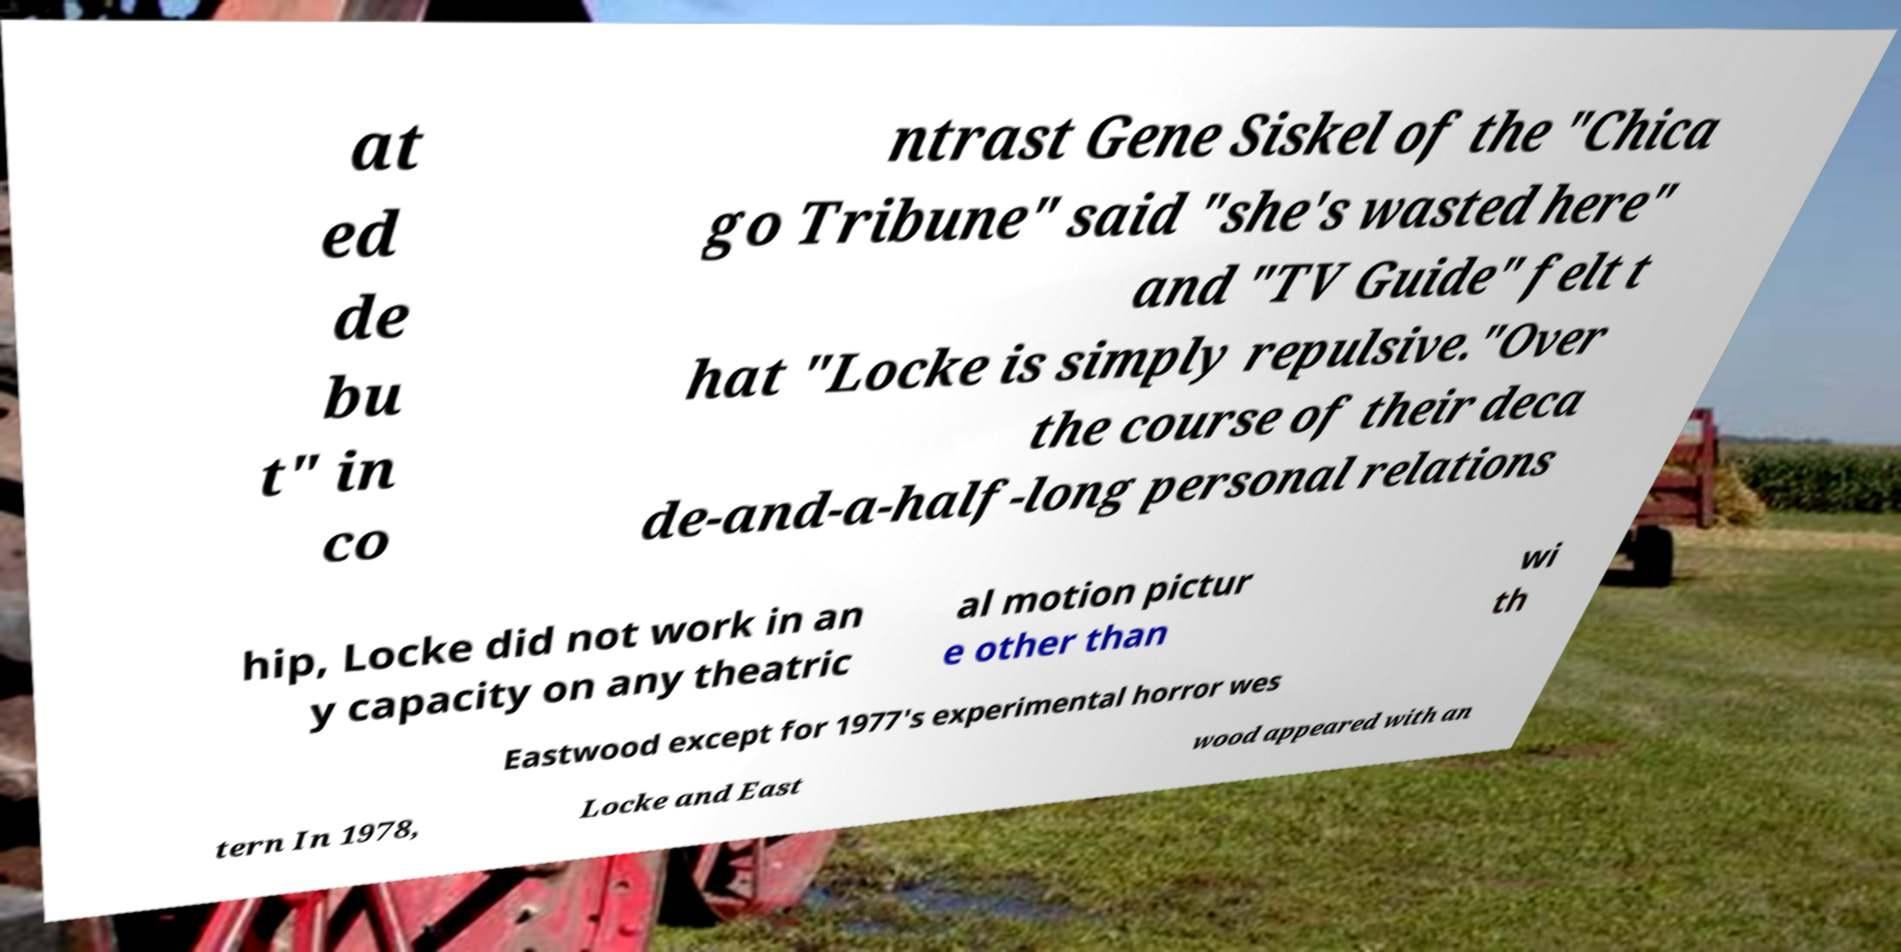Could you extract and type out the text from this image? at ed de bu t" in co ntrast Gene Siskel of the "Chica go Tribune" said "she's wasted here" and "TV Guide" felt t hat "Locke is simply repulsive."Over the course of their deca de-and-a-half-long personal relations hip, Locke did not work in an y capacity on any theatric al motion pictur e other than wi th Eastwood except for 1977's experimental horror wes tern In 1978, Locke and East wood appeared with an 